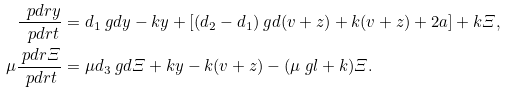Convert formula to latex. <formula><loc_0><loc_0><loc_500><loc_500>\frac { \ p d r y } { \ p d r t } & = d _ { 1 } \ g d y - k y + \left [ ( d _ { 2 } - d _ { 1 } ) \ g d ( v + z ) + k ( v + z ) + 2 a \right ] + k \varXi , \\ \mu \frac { \ p d r \varXi } { \ p d r t } & = \mu d _ { 3 } \ g d \varXi + k y - k ( v + z ) - ( \mu \ g l + k ) \varXi .</formula> 